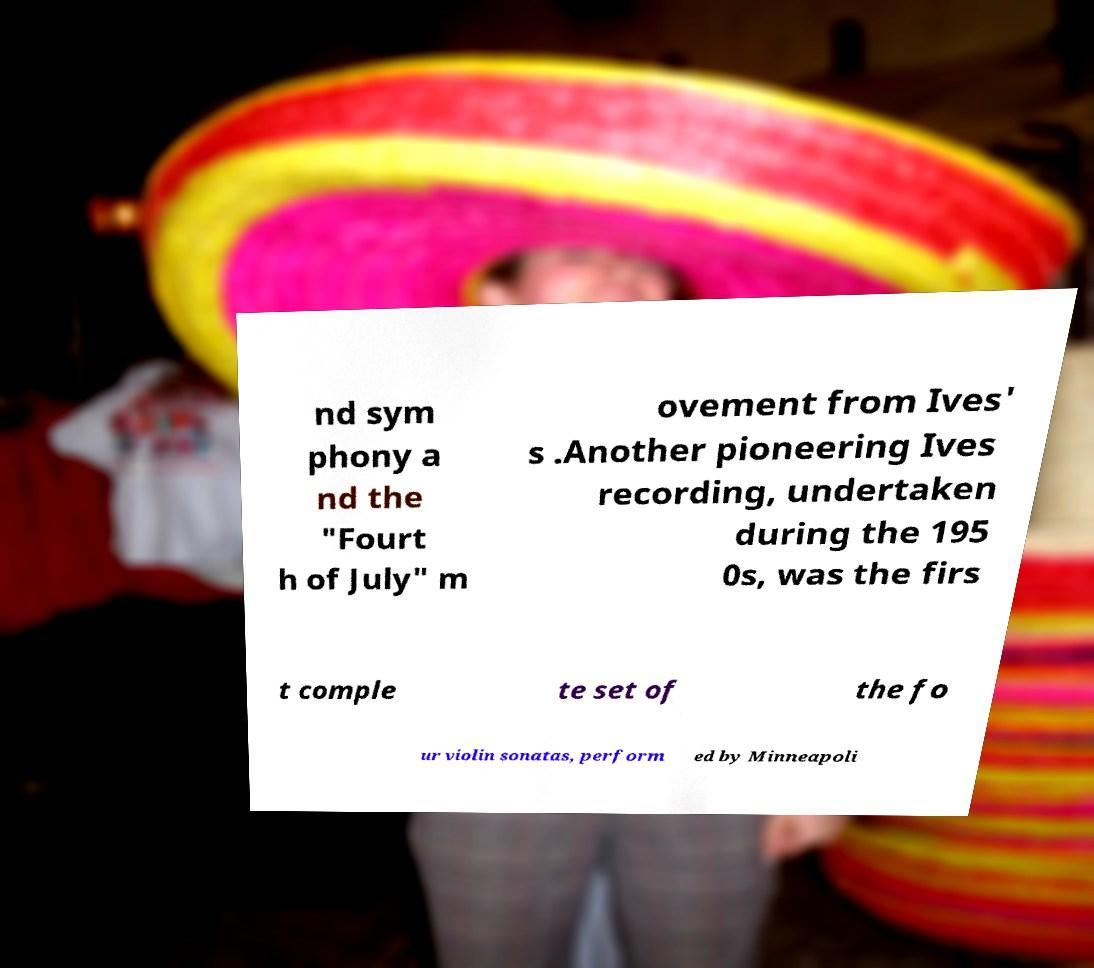Please identify and transcribe the text found in this image. nd sym phony a nd the "Fourt h of July" m ovement from Ives' s .Another pioneering Ives recording, undertaken during the 195 0s, was the firs t comple te set of the fo ur violin sonatas, perform ed by Minneapoli 